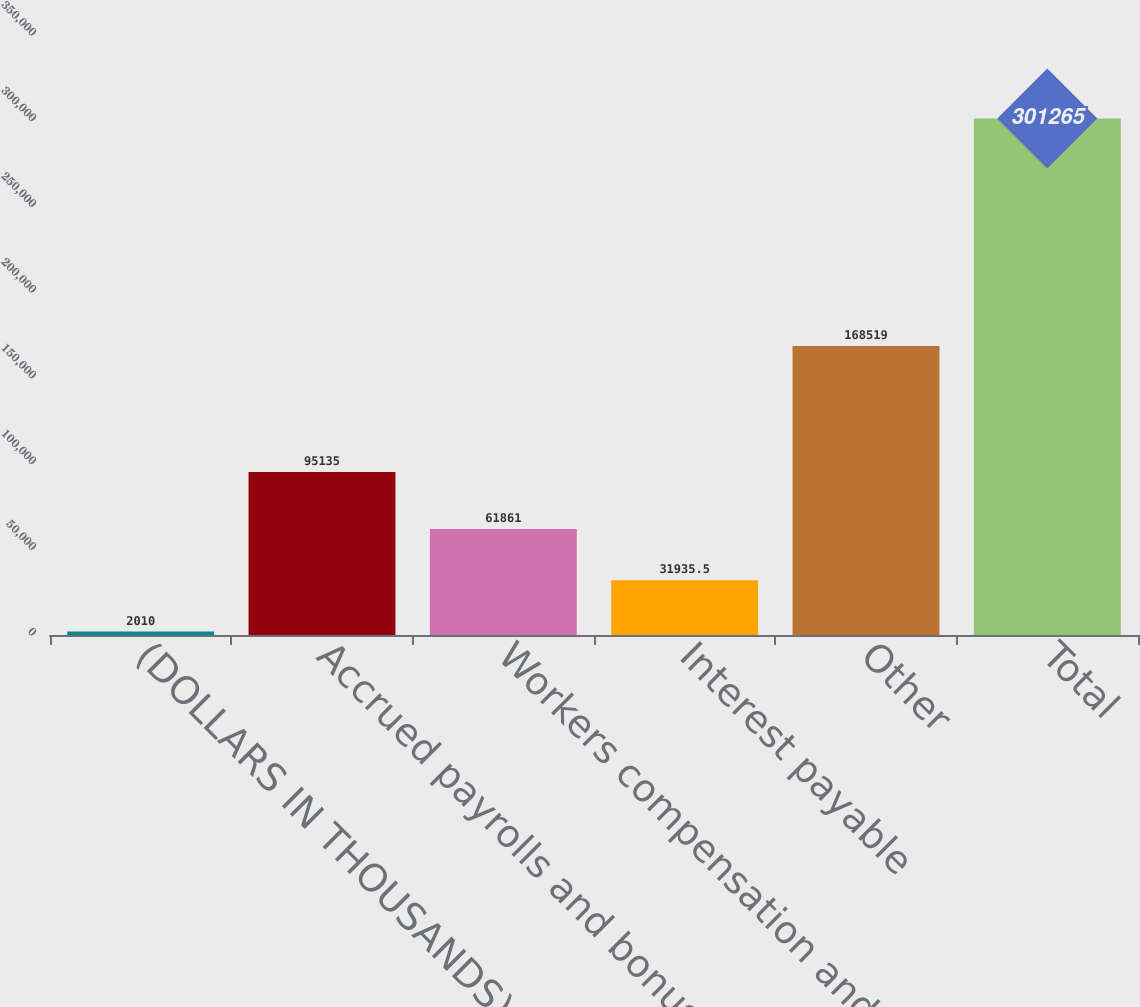Convert chart. <chart><loc_0><loc_0><loc_500><loc_500><bar_chart><fcel>(DOLLARS IN THOUSANDS)<fcel>Accrued payrolls and bonuses<fcel>Workers compensation and<fcel>Interest payable<fcel>Other<fcel>Total<nl><fcel>2010<fcel>95135<fcel>61861<fcel>31935.5<fcel>168519<fcel>301265<nl></chart> 